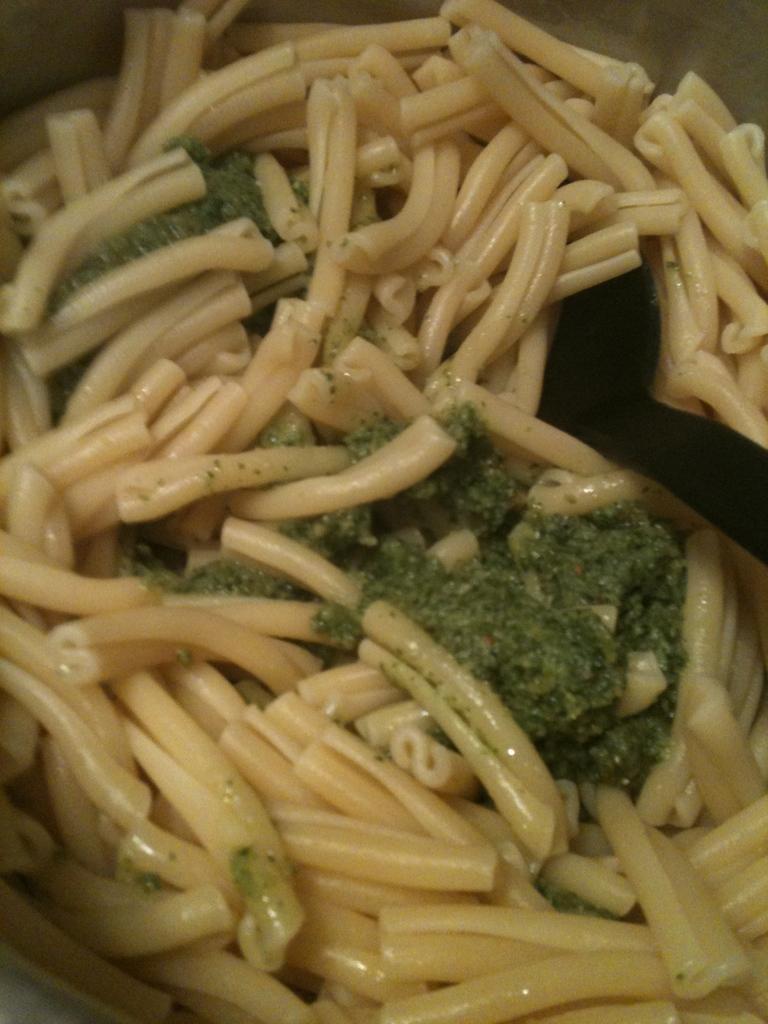How would you summarize this image in a sentence or two? There is a food item with pastas and green color thing on it. 